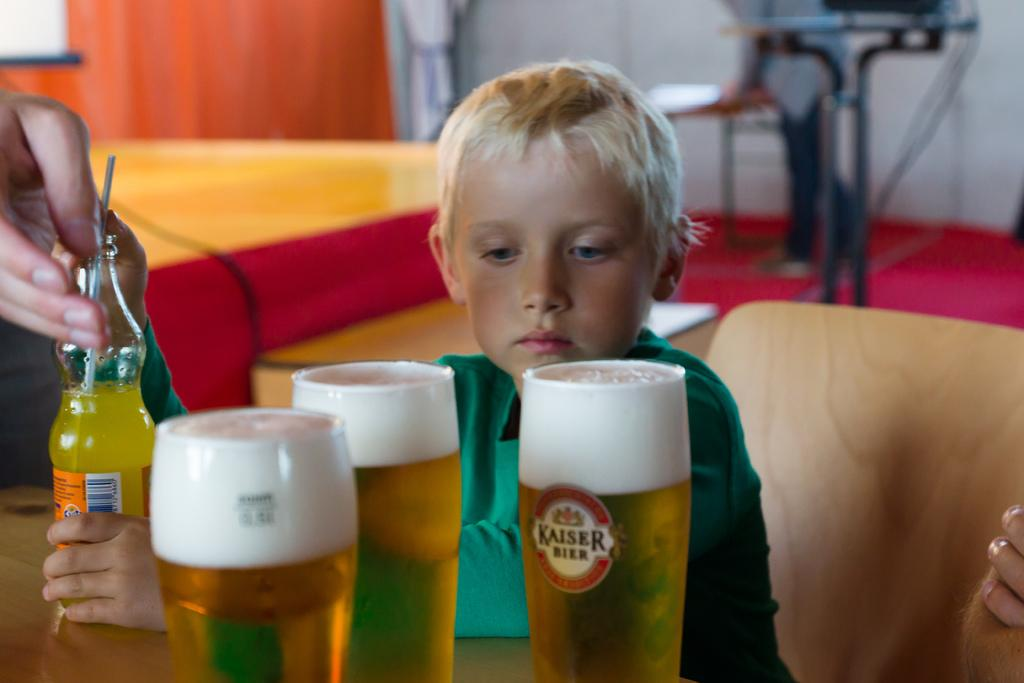Provide a one-sentence caption for the provided image. A young child staring at three full Kaiser Beer glasses. 